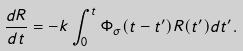Convert formula to latex. <formula><loc_0><loc_0><loc_500><loc_500>\frac { d R } { d t } = - k \int _ { 0 } ^ { t } \Phi _ { \sigma } ( t - t ^ { \prime } ) R ( t ^ { \prime } ) d t ^ { \prime } .</formula> 